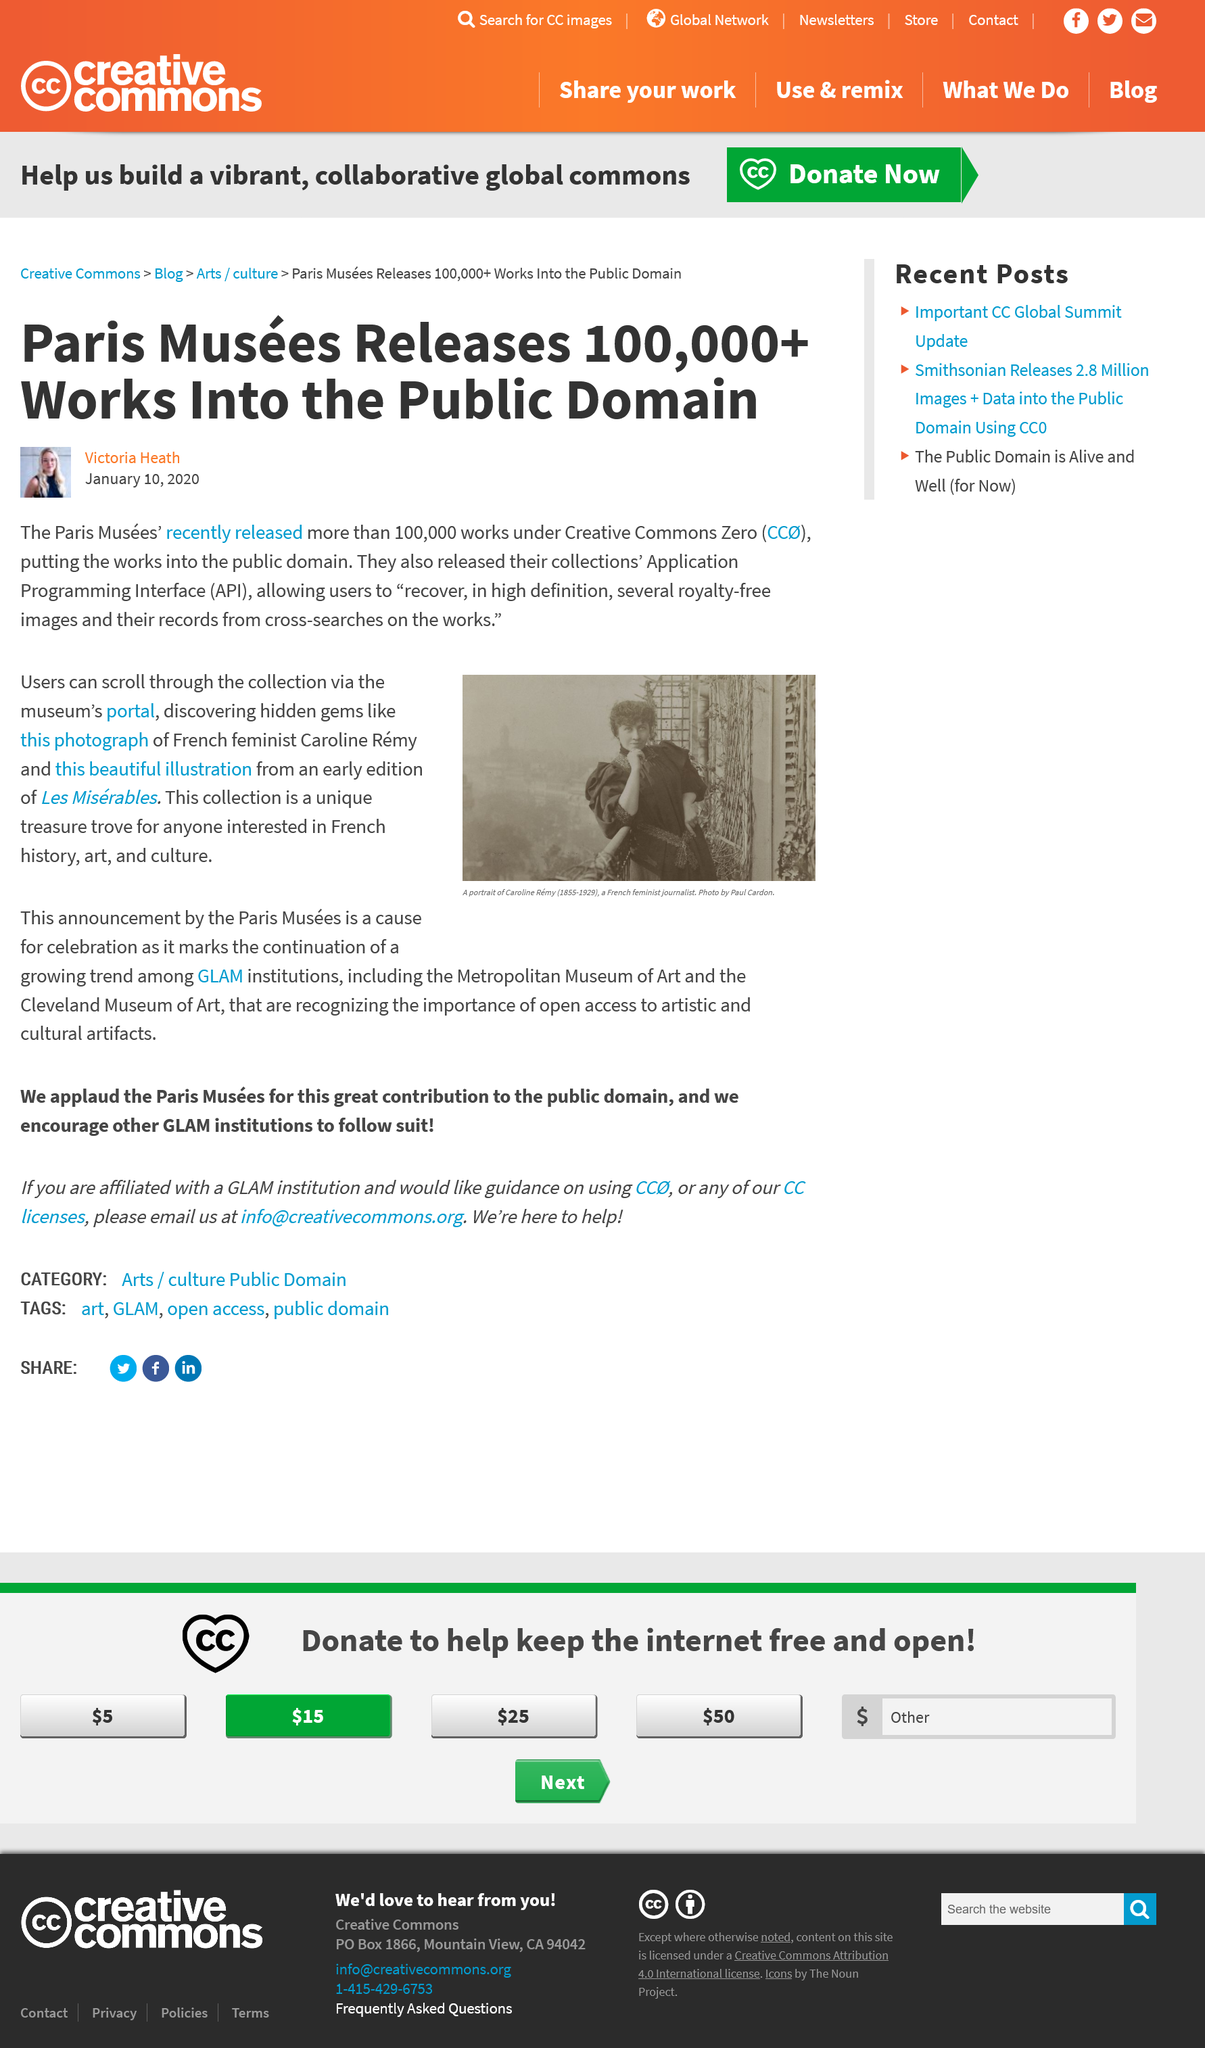Draw attention to some important aspects in this diagram. Creative Commons Zero means that the works are placed in the public domain, which means that they are not subject to any copyright restrictions and can be used by anyone for any purpose. The photographs, illustrations, and other materials can be accessed through the museum's portal. The API is used to recover images and records from cross-searches on the works of Leonardo da Vinci. 